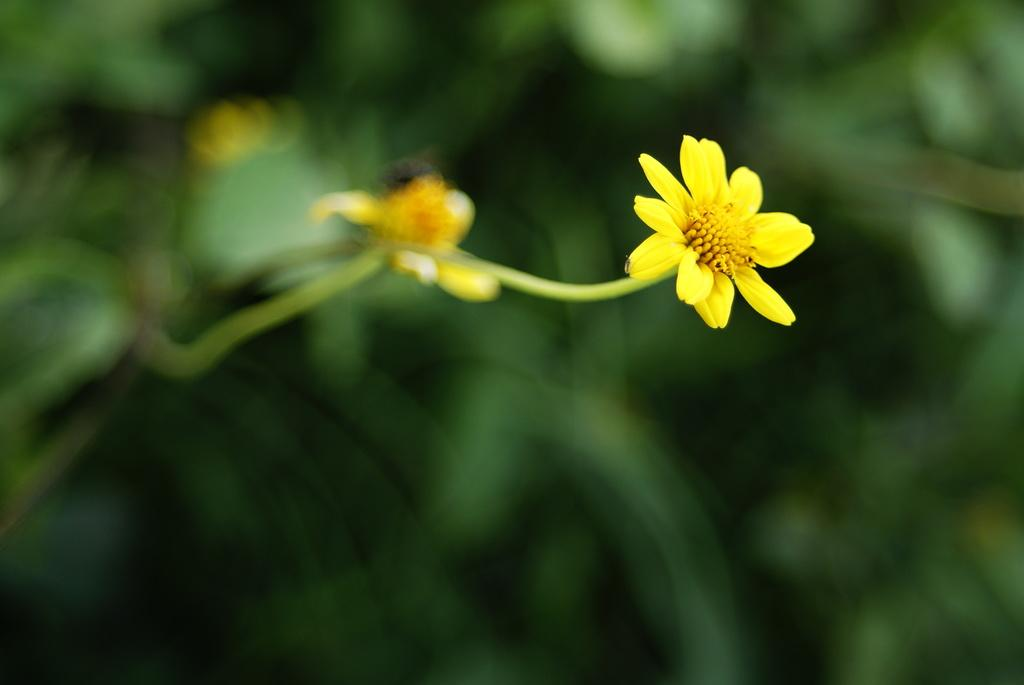What type of flowers can be seen in the image? There are two yellow flowers in the image. How are the flowers attached to the stems? The flowers are on stems. What color are the leaves in the background of the image? There are green leaves in the background of the image. Can you see anyone smiling near the lake in the image? There is no lake or anyone smiling in the image; it only features two yellow flowers on stems and green leaves in the background. 